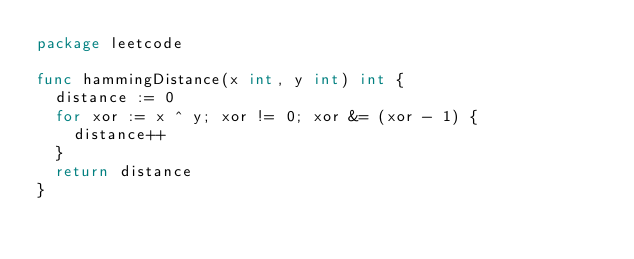<code> <loc_0><loc_0><loc_500><loc_500><_Go_>package leetcode

func hammingDistance(x int, y int) int {
	distance := 0
	for xor := x ^ y; xor != 0; xor &= (xor - 1) {
		distance++
	}
	return distance
}
</code> 